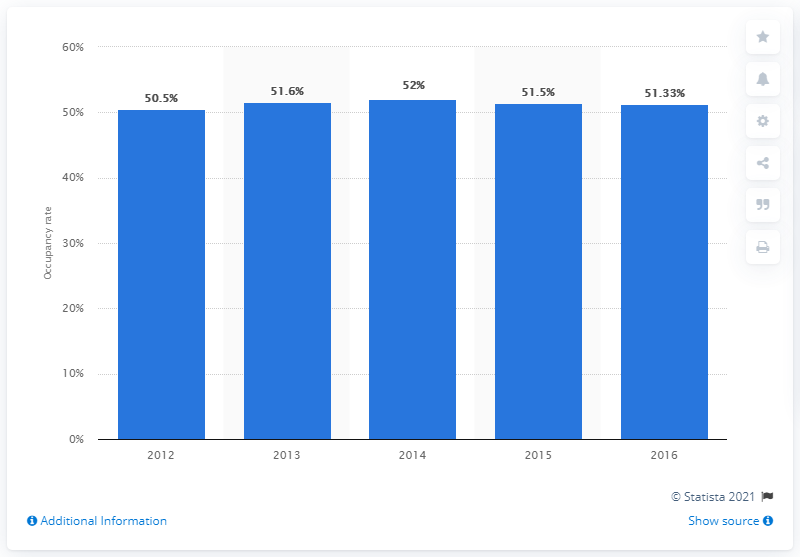Mention a couple of crucial points in this snapshot. In 2016, the highest recorded occupancy rate in Switzerland was 51.33%. In 2014, Switzerland achieved its highest recorded occupancy rate. 